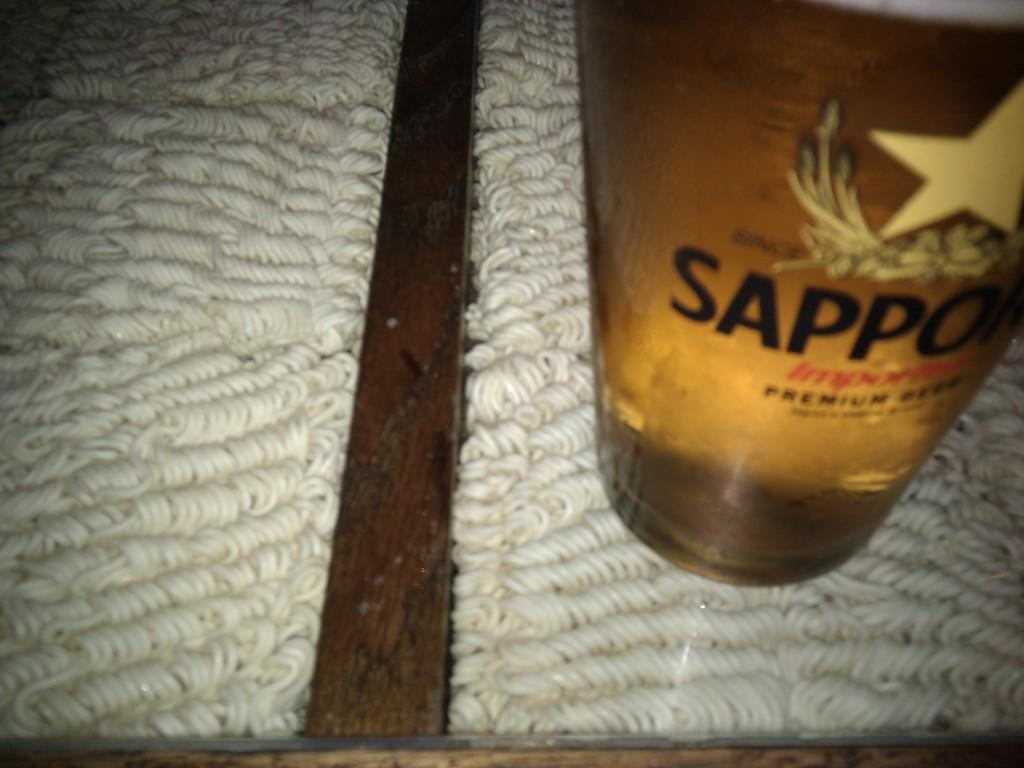<image>
Present a compact description of the photo's key features. A bottle of Sapporo beer sits on a tan carpet. 